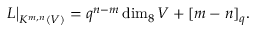<formula> <loc_0><loc_0><loc_500><loc_500>L \Big | _ { K ^ { m , n } ( V ) } = q ^ { n - m } \dim _ { 8 } V + [ m - n ] _ { q } .</formula> 